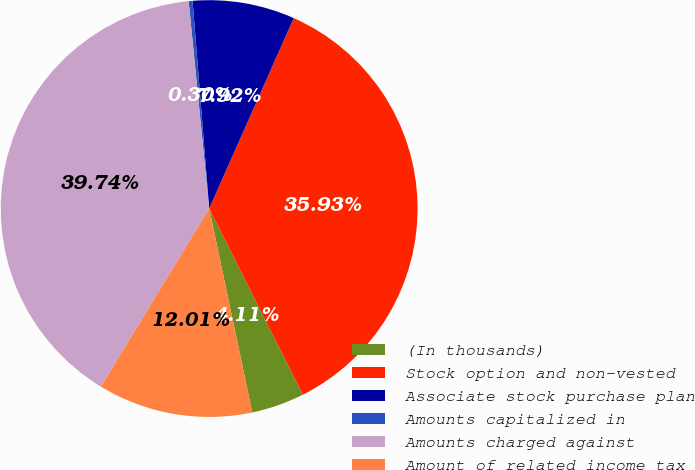Convert chart to OTSL. <chart><loc_0><loc_0><loc_500><loc_500><pie_chart><fcel>(In thousands)<fcel>Stock option and non-vested<fcel>Associate stock purchase plan<fcel>Amounts capitalized in<fcel>Amounts charged against<fcel>Amount of related income tax<nl><fcel>4.11%<fcel>35.93%<fcel>7.92%<fcel>0.3%<fcel>39.74%<fcel>12.01%<nl></chart> 